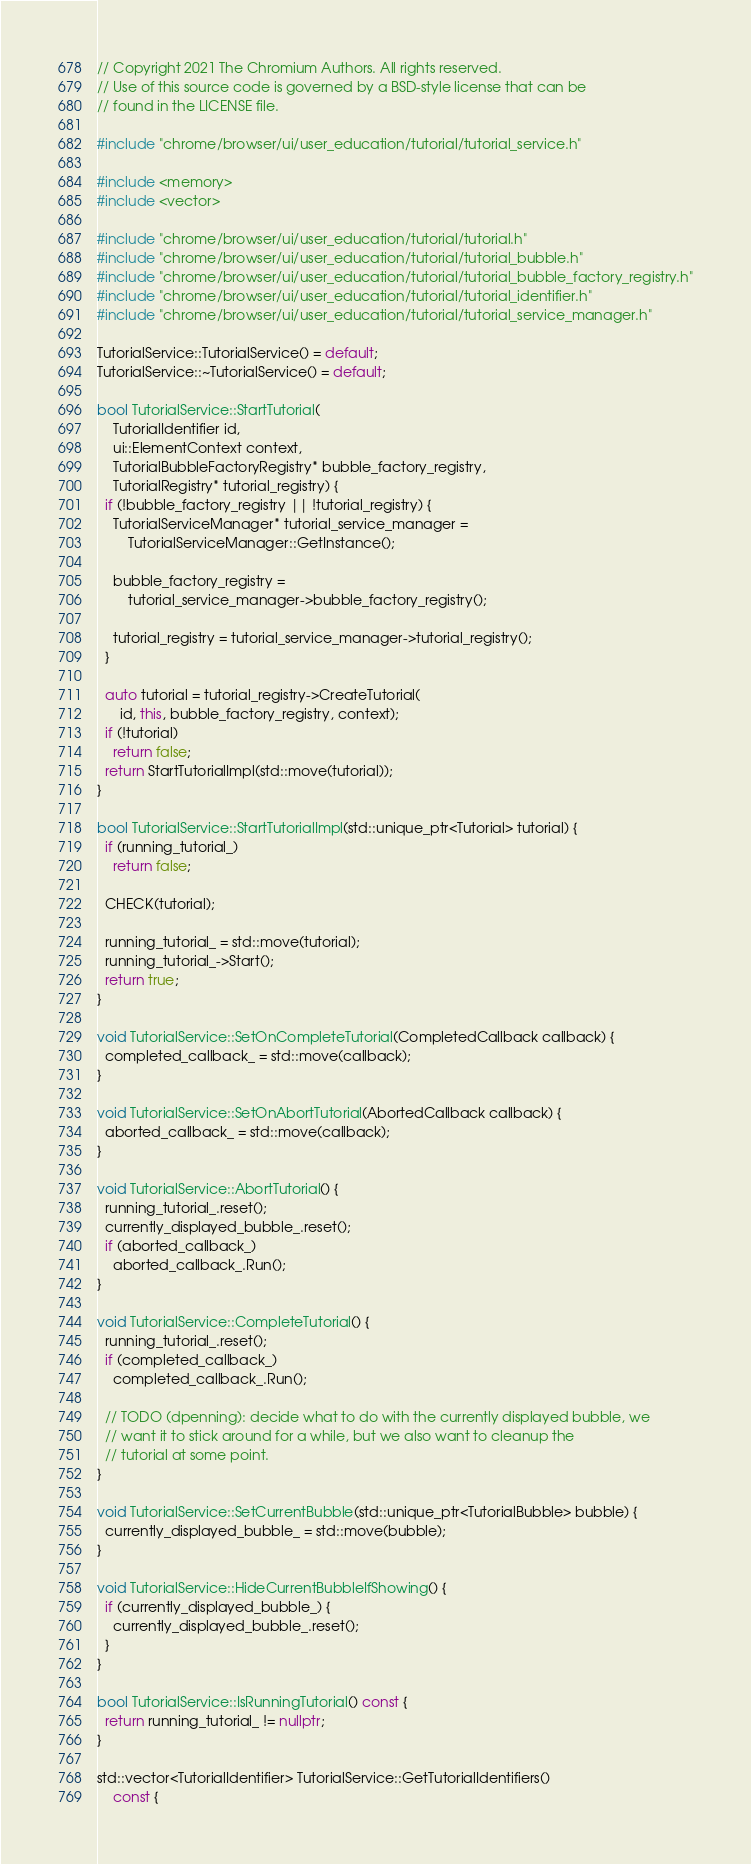Convert code to text. <code><loc_0><loc_0><loc_500><loc_500><_C++_>// Copyright 2021 The Chromium Authors. All rights reserved.
// Use of this source code is governed by a BSD-style license that can be
// found in the LICENSE file.

#include "chrome/browser/ui/user_education/tutorial/tutorial_service.h"

#include <memory>
#include <vector>

#include "chrome/browser/ui/user_education/tutorial/tutorial.h"
#include "chrome/browser/ui/user_education/tutorial/tutorial_bubble.h"
#include "chrome/browser/ui/user_education/tutorial/tutorial_bubble_factory_registry.h"
#include "chrome/browser/ui/user_education/tutorial/tutorial_identifier.h"
#include "chrome/browser/ui/user_education/tutorial/tutorial_service_manager.h"

TutorialService::TutorialService() = default;
TutorialService::~TutorialService() = default;

bool TutorialService::StartTutorial(
    TutorialIdentifier id,
    ui::ElementContext context,
    TutorialBubbleFactoryRegistry* bubble_factory_registry,
    TutorialRegistry* tutorial_registry) {
  if (!bubble_factory_registry || !tutorial_registry) {
    TutorialServiceManager* tutorial_service_manager =
        TutorialServiceManager::GetInstance();

    bubble_factory_registry =
        tutorial_service_manager->bubble_factory_registry();

    tutorial_registry = tutorial_service_manager->tutorial_registry();
  }

  auto tutorial = tutorial_registry->CreateTutorial(
      id, this, bubble_factory_registry, context);
  if (!tutorial)
    return false;
  return StartTutorialImpl(std::move(tutorial));
}

bool TutorialService::StartTutorialImpl(std::unique_ptr<Tutorial> tutorial) {
  if (running_tutorial_)
    return false;

  CHECK(tutorial);

  running_tutorial_ = std::move(tutorial);
  running_tutorial_->Start();
  return true;
}

void TutorialService::SetOnCompleteTutorial(CompletedCallback callback) {
  completed_callback_ = std::move(callback);
}

void TutorialService::SetOnAbortTutorial(AbortedCallback callback) {
  aborted_callback_ = std::move(callback);
}

void TutorialService::AbortTutorial() {
  running_tutorial_.reset();
  currently_displayed_bubble_.reset();
  if (aborted_callback_)
    aborted_callback_.Run();
}

void TutorialService::CompleteTutorial() {
  running_tutorial_.reset();
  if (completed_callback_)
    completed_callback_.Run();

  // TODO (dpenning): decide what to do with the currently displayed bubble, we
  // want it to stick around for a while, but we also want to cleanup the
  // tutorial at some point.
}

void TutorialService::SetCurrentBubble(std::unique_ptr<TutorialBubble> bubble) {
  currently_displayed_bubble_ = std::move(bubble);
}

void TutorialService::HideCurrentBubbleIfShowing() {
  if (currently_displayed_bubble_) {
    currently_displayed_bubble_.reset();
  }
}

bool TutorialService::IsRunningTutorial() const {
  return running_tutorial_ != nullptr;
}

std::vector<TutorialIdentifier> TutorialService::GetTutorialIdentifiers()
    const {</code> 